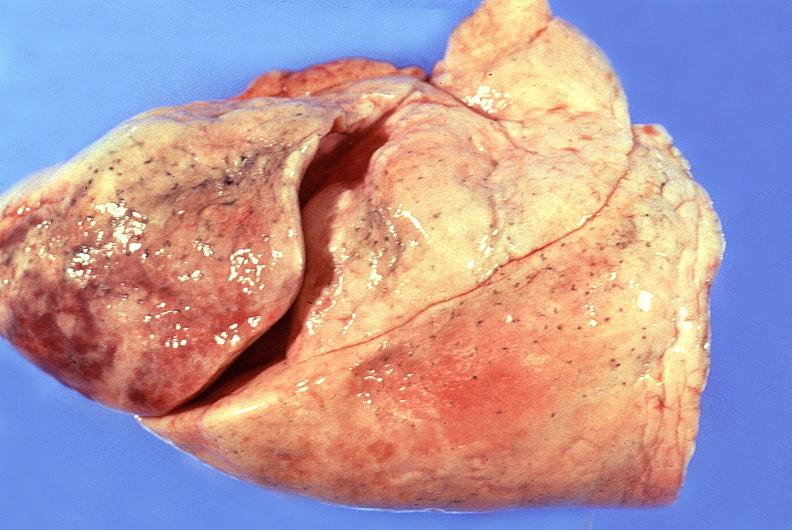what is present?
Answer the question using a single word or phrase. Respiratory 